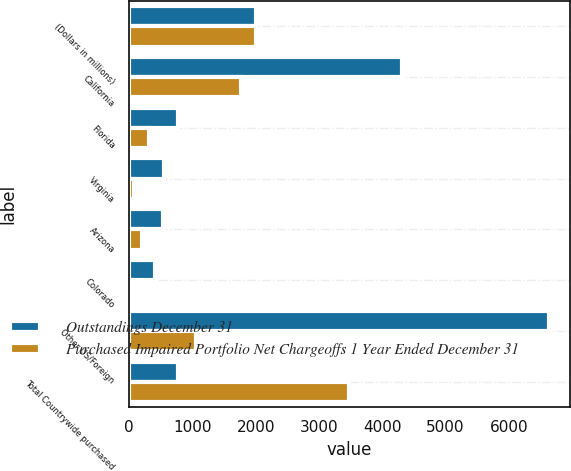Convert chart to OTSL. <chart><loc_0><loc_0><loc_500><loc_500><stacked_bar_chart><ecel><fcel>(Dollars in millions)<fcel>California<fcel>Florida<fcel>Virginia<fcel>Arizona<fcel>Colorado<fcel>Other US/Foreign<fcel>Total Countrywide purchased<nl><fcel>Outstandings December 31<fcel>2009<fcel>4311<fcel>765<fcel>550<fcel>542<fcel>416<fcel>6630<fcel>765<nl><fcel>Purchased Impaired Portfolio Net Chargeoffs 1 Year Ended December 31<fcel>2009<fcel>1769<fcel>320<fcel>77<fcel>203<fcel>48<fcel>1057<fcel>3474<nl></chart> 